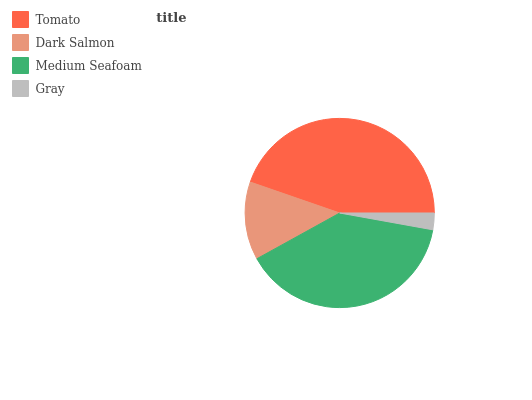Is Gray the minimum?
Answer yes or no. Yes. Is Tomato the maximum?
Answer yes or no. Yes. Is Dark Salmon the minimum?
Answer yes or no. No. Is Dark Salmon the maximum?
Answer yes or no. No. Is Tomato greater than Dark Salmon?
Answer yes or no. Yes. Is Dark Salmon less than Tomato?
Answer yes or no. Yes. Is Dark Salmon greater than Tomato?
Answer yes or no. No. Is Tomato less than Dark Salmon?
Answer yes or no. No. Is Medium Seafoam the high median?
Answer yes or no. Yes. Is Dark Salmon the low median?
Answer yes or no. Yes. Is Dark Salmon the high median?
Answer yes or no. No. Is Tomato the low median?
Answer yes or no. No. 